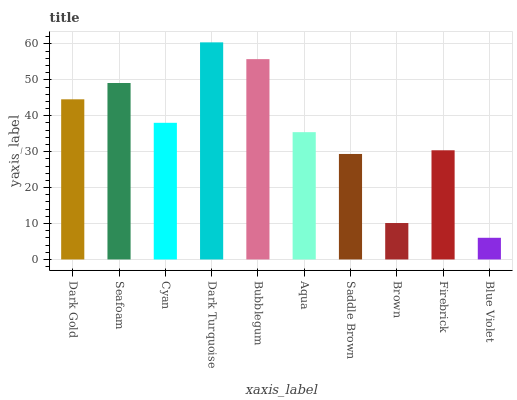Is Blue Violet the minimum?
Answer yes or no. Yes. Is Dark Turquoise the maximum?
Answer yes or no. Yes. Is Seafoam the minimum?
Answer yes or no. No. Is Seafoam the maximum?
Answer yes or no. No. Is Seafoam greater than Dark Gold?
Answer yes or no. Yes. Is Dark Gold less than Seafoam?
Answer yes or no. Yes. Is Dark Gold greater than Seafoam?
Answer yes or no. No. Is Seafoam less than Dark Gold?
Answer yes or no. No. Is Cyan the high median?
Answer yes or no. Yes. Is Aqua the low median?
Answer yes or no. Yes. Is Saddle Brown the high median?
Answer yes or no. No. Is Brown the low median?
Answer yes or no. No. 